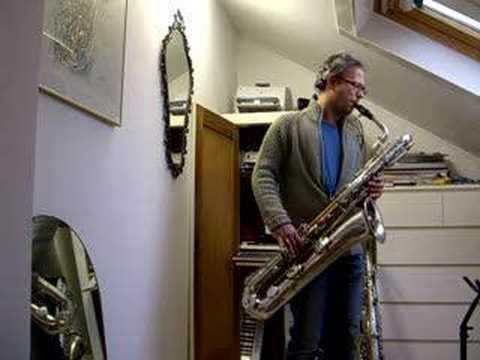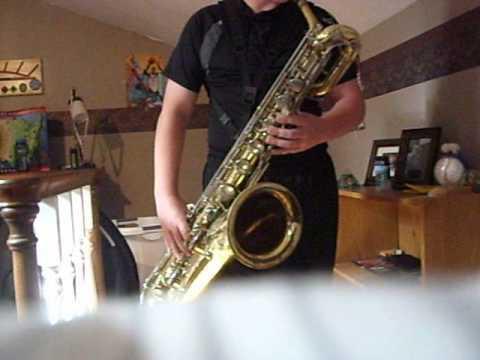The first image is the image on the left, the second image is the image on the right. Given the left and right images, does the statement "A person wearing glasses holds a saxophone in the left image." hold true? Answer yes or no. Yes. The first image is the image on the left, the second image is the image on the right. Analyze the images presented: Is the assertion "An image shows a person in a green shirt and jeans holding an instrument." valid? Answer yes or no. No. 